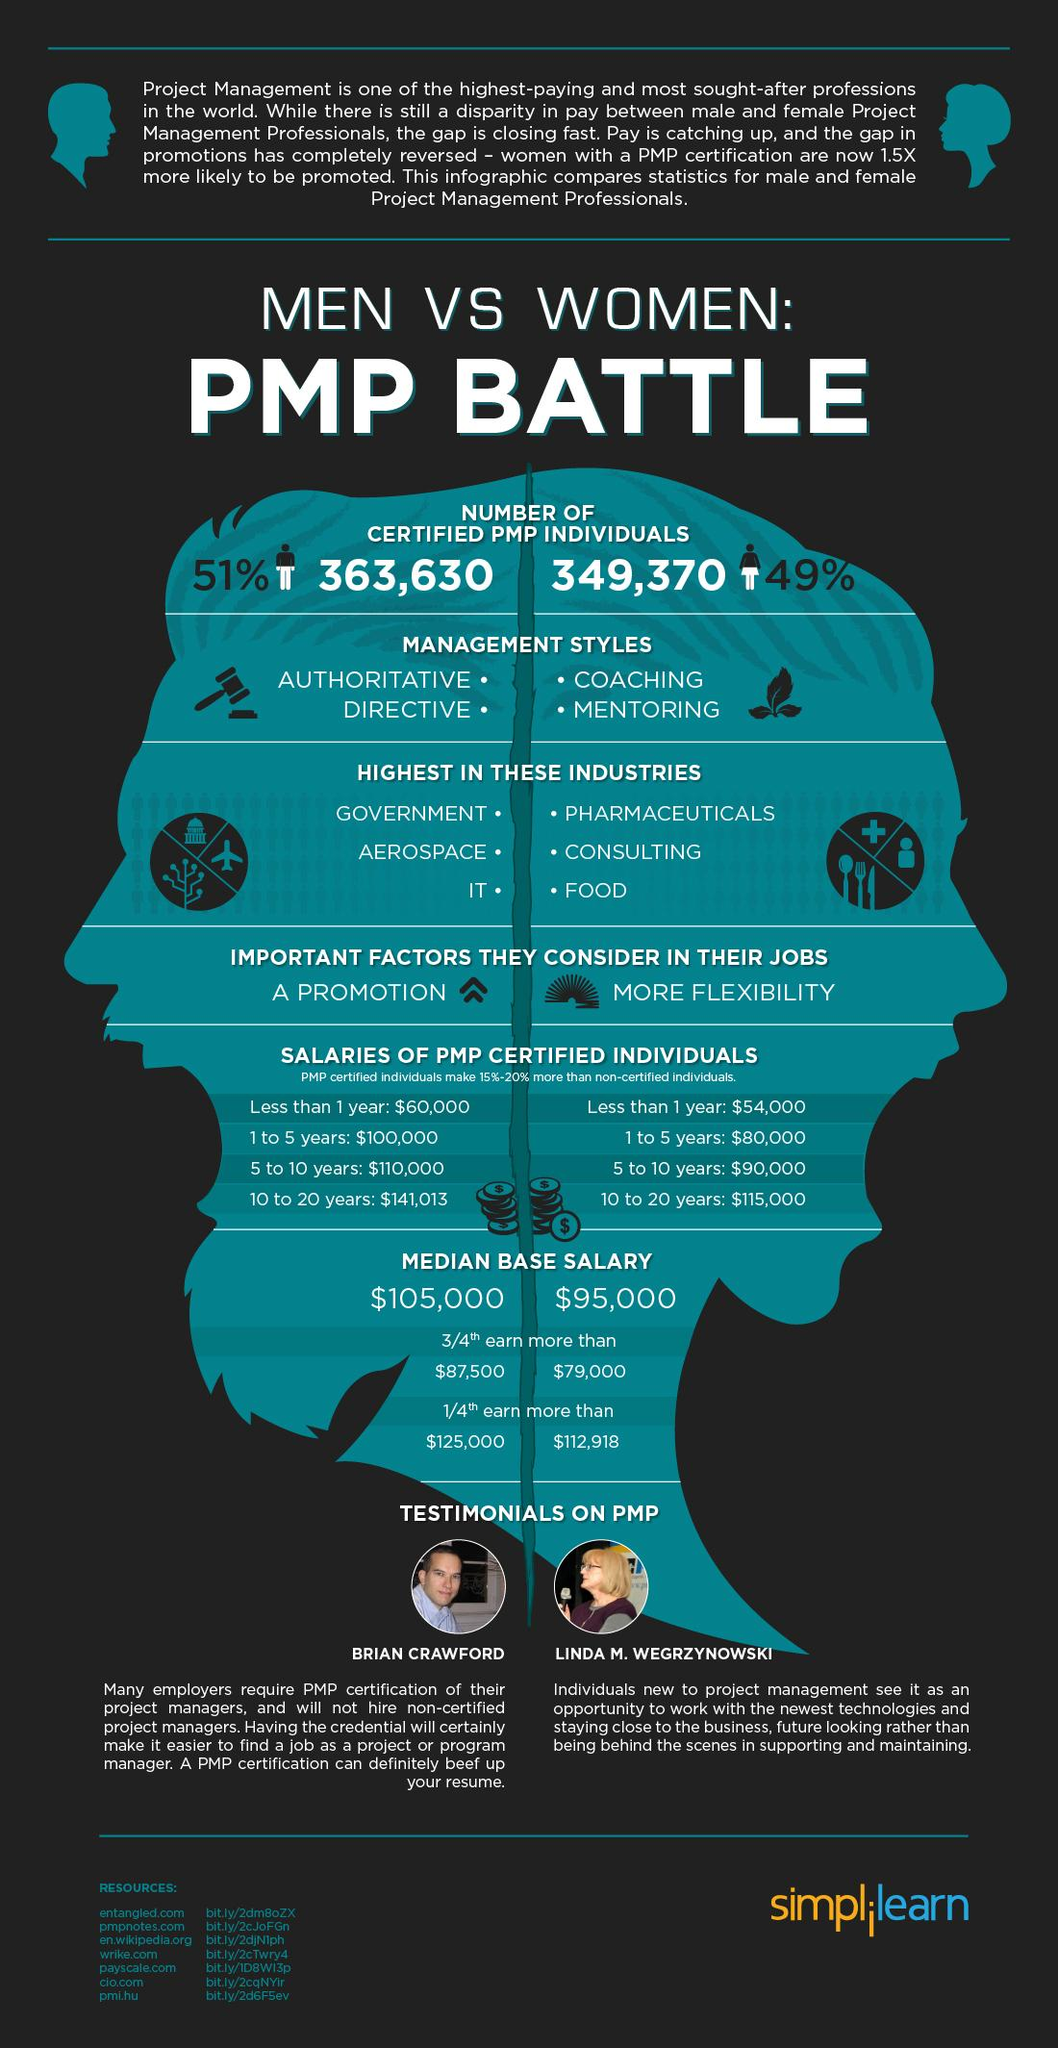Highlight a few significant elements in this photo. The management style of PMP certified men is authoritative, directive, and possibly mentoring. As of September 2021, there were 349,370 PMP certified women. The PMP certified professionals have a significantly larger gap in their experience compared to non-certified professionals with 10 to 20 years of experience. According to the data, the industries with the highest percentage of PMP certified women are Pharmaceuticals and Consulting. 